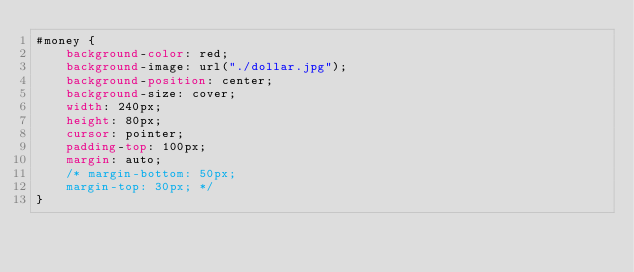<code> <loc_0><loc_0><loc_500><loc_500><_CSS_>#money {
    background-color: red;
    background-image: url("./dollar.jpg");
    background-position: center;
    background-size: cover;
    width: 240px;
    height: 80px;
    cursor: pointer;
    padding-top: 100px;
    margin: auto;
    /* margin-bottom: 50px;
    margin-top: 30px; */
}</code> 